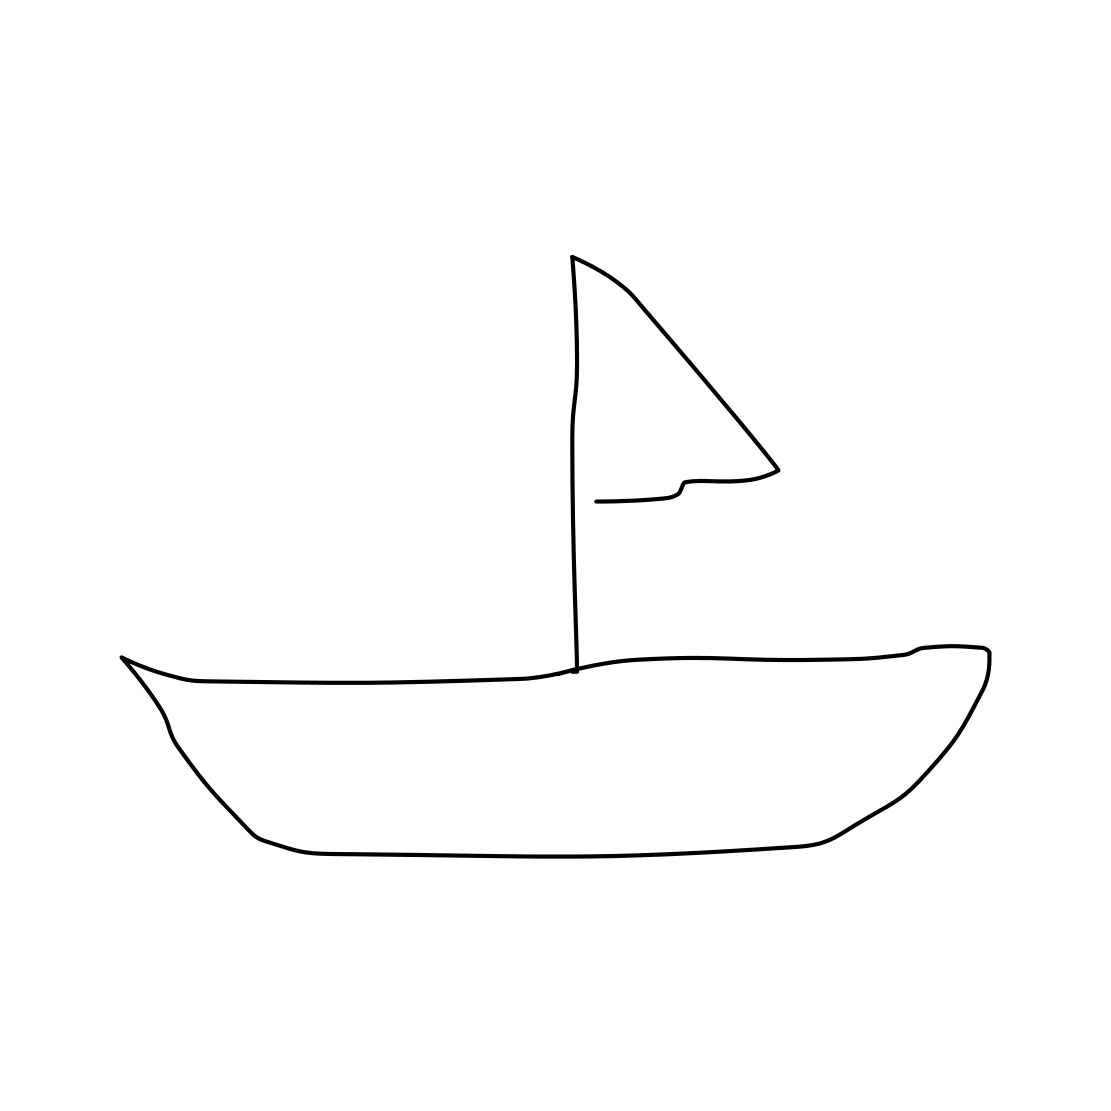Is there a sketchy cow in the picture? No 